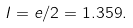Convert formula to latex. <formula><loc_0><loc_0><loc_500><loc_500>I = e / 2 = 1 . 3 5 9 .</formula> 